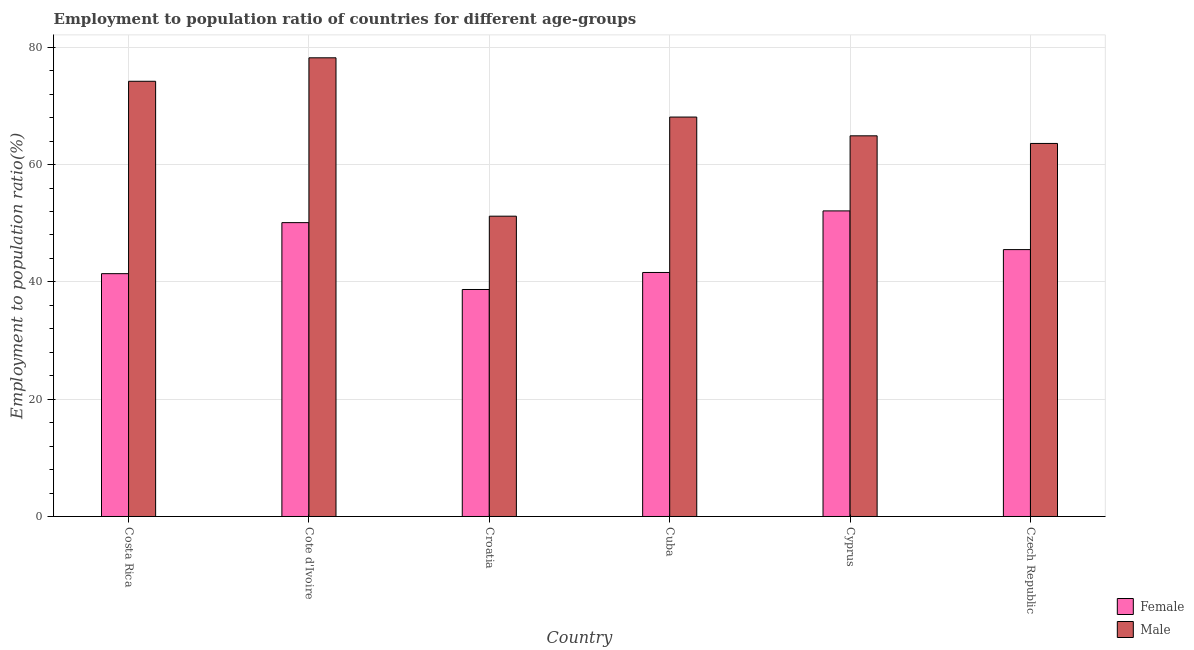How many different coloured bars are there?
Provide a short and direct response. 2. How many groups of bars are there?
Offer a very short reply. 6. Are the number of bars per tick equal to the number of legend labels?
Ensure brevity in your answer.  Yes. Are the number of bars on each tick of the X-axis equal?
Offer a very short reply. Yes. What is the label of the 6th group of bars from the left?
Ensure brevity in your answer.  Czech Republic. In how many cases, is the number of bars for a given country not equal to the number of legend labels?
Provide a succinct answer. 0. What is the employment to population ratio(female) in Cyprus?
Your response must be concise. 52.1. Across all countries, what is the maximum employment to population ratio(male)?
Keep it short and to the point. 78.2. Across all countries, what is the minimum employment to population ratio(male)?
Your answer should be compact. 51.2. In which country was the employment to population ratio(female) maximum?
Your answer should be compact. Cyprus. In which country was the employment to population ratio(female) minimum?
Provide a succinct answer. Croatia. What is the total employment to population ratio(female) in the graph?
Your response must be concise. 269.4. What is the difference between the employment to population ratio(male) in Cote d'Ivoire and that in Croatia?
Make the answer very short. 27. What is the difference between the employment to population ratio(male) in Cuba and the employment to population ratio(female) in Cote d'Ivoire?
Your answer should be very brief. 18. What is the average employment to population ratio(male) per country?
Keep it short and to the point. 66.7. What is the difference between the employment to population ratio(male) and employment to population ratio(female) in Cyprus?
Keep it short and to the point. 12.8. What is the ratio of the employment to population ratio(male) in Cote d'Ivoire to that in Cuba?
Your response must be concise. 1.15. Is the employment to population ratio(female) in Costa Rica less than that in Cyprus?
Keep it short and to the point. Yes. Is the difference between the employment to population ratio(female) in Croatia and Cuba greater than the difference between the employment to population ratio(male) in Croatia and Cuba?
Provide a succinct answer. Yes. What is the difference between the highest and the lowest employment to population ratio(female)?
Give a very brief answer. 13.4. In how many countries, is the employment to population ratio(male) greater than the average employment to population ratio(male) taken over all countries?
Ensure brevity in your answer.  3. What does the 1st bar from the left in Costa Rica represents?
Give a very brief answer. Female. What does the 2nd bar from the right in Cote d'Ivoire represents?
Provide a succinct answer. Female. What is the difference between two consecutive major ticks on the Y-axis?
Give a very brief answer. 20. Where does the legend appear in the graph?
Offer a very short reply. Bottom right. How many legend labels are there?
Ensure brevity in your answer.  2. What is the title of the graph?
Make the answer very short. Employment to population ratio of countries for different age-groups. Does "From World Bank" appear as one of the legend labels in the graph?
Make the answer very short. No. What is the label or title of the X-axis?
Offer a very short reply. Country. What is the label or title of the Y-axis?
Your answer should be very brief. Employment to population ratio(%). What is the Employment to population ratio(%) of Female in Costa Rica?
Your answer should be very brief. 41.4. What is the Employment to population ratio(%) of Male in Costa Rica?
Your answer should be very brief. 74.2. What is the Employment to population ratio(%) of Female in Cote d'Ivoire?
Provide a succinct answer. 50.1. What is the Employment to population ratio(%) of Male in Cote d'Ivoire?
Ensure brevity in your answer.  78.2. What is the Employment to population ratio(%) of Female in Croatia?
Keep it short and to the point. 38.7. What is the Employment to population ratio(%) in Male in Croatia?
Keep it short and to the point. 51.2. What is the Employment to population ratio(%) of Female in Cuba?
Ensure brevity in your answer.  41.6. What is the Employment to population ratio(%) in Male in Cuba?
Offer a terse response. 68.1. What is the Employment to population ratio(%) of Female in Cyprus?
Your answer should be very brief. 52.1. What is the Employment to population ratio(%) in Male in Cyprus?
Offer a very short reply. 64.9. What is the Employment to population ratio(%) of Female in Czech Republic?
Give a very brief answer. 45.5. What is the Employment to population ratio(%) of Male in Czech Republic?
Offer a terse response. 63.6. Across all countries, what is the maximum Employment to population ratio(%) of Female?
Your answer should be very brief. 52.1. Across all countries, what is the maximum Employment to population ratio(%) in Male?
Provide a succinct answer. 78.2. Across all countries, what is the minimum Employment to population ratio(%) in Female?
Offer a very short reply. 38.7. Across all countries, what is the minimum Employment to population ratio(%) in Male?
Your answer should be compact. 51.2. What is the total Employment to population ratio(%) in Female in the graph?
Your response must be concise. 269.4. What is the total Employment to population ratio(%) in Male in the graph?
Provide a short and direct response. 400.2. What is the difference between the Employment to population ratio(%) of Male in Costa Rica and that in Cote d'Ivoire?
Ensure brevity in your answer.  -4. What is the difference between the Employment to population ratio(%) of Male in Costa Rica and that in Croatia?
Provide a short and direct response. 23. What is the difference between the Employment to population ratio(%) of Female in Costa Rica and that in Cyprus?
Offer a very short reply. -10.7. What is the difference between the Employment to population ratio(%) of Male in Costa Rica and that in Czech Republic?
Offer a very short reply. 10.6. What is the difference between the Employment to population ratio(%) in Male in Cote d'Ivoire and that in Croatia?
Provide a succinct answer. 27. What is the difference between the Employment to population ratio(%) in Female in Cote d'Ivoire and that in Cyprus?
Make the answer very short. -2. What is the difference between the Employment to population ratio(%) in Male in Cote d'Ivoire and that in Czech Republic?
Ensure brevity in your answer.  14.6. What is the difference between the Employment to population ratio(%) of Male in Croatia and that in Cuba?
Keep it short and to the point. -16.9. What is the difference between the Employment to population ratio(%) in Female in Croatia and that in Cyprus?
Give a very brief answer. -13.4. What is the difference between the Employment to population ratio(%) of Male in Croatia and that in Cyprus?
Your answer should be compact. -13.7. What is the difference between the Employment to population ratio(%) of Male in Croatia and that in Czech Republic?
Offer a terse response. -12.4. What is the difference between the Employment to population ratio(%) of Male in Cuba and that in Cyprus?
Ensure brevity in your answer.  3.2. What is the difference between the Employment to population ratio(%) in Male in Cuba and that in Czech Republic?
Your answer should be very brief. 4.5. What is the difference between the Employment to population ratio(%) of Female in Cyprus and that in Czech Republic?
Provide a succinct answer. 6.6. What is the difference between the Employment to population ratio(%) of Male in Cyprus and that in Czech Republic?
Your answer should be compact. 1.3. What is the difference between the Employment to population ratio(%) of Female in Costa Rica and the Employment to population ratio(%) of Male in Cote d'Ivoire?
Your response must be concise. -36.8. What is the difference between the Employment to population ratio(%) in Female in Costa Rica and the Employment to population ratio(%) in Male in Croatia?
Offer a terse response. -9.8. What is the difference between the Employment to population ratio(%) of Female in Costa Rica and the Employment to population ratio(%) of Male in Cuba?
Ensure brevity in your answer.  -26.7. What is the difference between the Employment to population ratio(%) of Female in Costa Rica and the Employment to population ratio(%) of Male in Cyprus?
Keep it short and to the point. -23.5. What is the difference between the Employment to population ratio(%) in Female in Costa Rica and the Employment to population ratio(%) in Male in Czech Republic?
Offer a terse response. -22.2. What is the difference between the Employment to population ratio(%) of Female in Cote d'Ivoire and the Employment to population ratio(%) of Male in Cyprus?
Give a very brief answer. -14.8. What is the difference between the Employment to population ratio(%) of Female in Croatia and the Employment to population ratio(%) of Male in Cuba?
Offer a very short reply. -29.4. What is the difference between the Employment to population ratio(%) in Female in Croatia and the Employment to population ratio(%) in Male in Cyprus?
Your response must be concise. -26.2. What is the difference between the Employment to population ratio(%) of Female in Croatia and the Employment to population ratio(%) of Male in Czech Republic?
Your answer should be very brief. -24.9. What is the difference between the Employment to population ratio(%) in Female in Cuba and the Employment to population ratio(%) in Male in Cyprus?
Provide a short and direct response. -23.3. What is the average Employment to population ratio(%) in Female per country?
Provide a short and direct response. 44.9. What is the average Employment to population ratio(%) of Male per country?
Provide a short and direct response. 66.7. What is the difference between the Employment to population ratio(%) in Female and Employment to population ratio(%) in Male in Costa Rica?
Your answer should be very brief. -32.8. What is the difference between the Employment to population ratio(%) of Female and Employment to population ratio(%) of Male in Cote d'Ivoire?
Give a very brief answer. -28.1. What is the difference between the Employment to population ratio(%) of Female and Employment to population ratio(%) of Male in Croatia?
Keep it short and to the point. -12.5. What is the difference between the Employment to population ratio(%) in Female and Employment to population ratio(%) in Male in Cuba?
Ensure brevity in your answer.  -26.5. What is the difference between the Employment to population ratio(%) in Female and Employment to population ratio(%) in Male in Cyprus?
Your answer should be compact. -12.8. What is the difference between the Employment to population ratio(%) of Female and Employment to population ratio(%) of Male in Czech Republic?
Your answer should be very brief. -18.1. What is the ratio of the Employment to population ratio(%) in Female in Costa Rica to that in Cote d'Ivoire?
Your response must be concise. 0.83. What is the ratio of the Employment to population ratio(%) of Male in Costa Rica to that in Cote d'Ivoire?
Make the answer very short. 0.95. What is the ratio of the Employment to population ratio(%) in Female in Costa Rica to that in Croatia?
Keep it short and to the point. 1.07. What is the ratio of the Employment to population ratio(%) of Male in Costa Rica to that in Croatia?
Provide a succinct answer. 1.45. What is the ratio of the Employment to population ratio(%) of Female in Costa Rica to that in Cuba?
Your response must be concise. 1. What is the ratio of the Employment to population ratio(%) of Male in Costa Rica to that in Cuba?
Your answer should be compact. 1.09. What is the ratio of the Employment to population ratio(%) in Female in Costa Rica to that in Cyprus?
Make the answer very short. 0.79. What is the ratio of the Employment to population ratio(%) in Male in Costa Rica to that in Cyprus?
Give a very brief answer. 1.14. What is the ratio of the Employment to population ratio(%) of Female in Costa Rica to that in Czech Republic?
Offer a very short reply. 0.91. What is the ratio of the Employment to population ratio(%) in Male in Costa Rica to that in Czech Republic?
Give a very brief answer. 1.17. What is the ratio of the Employment to population ratio(%) of Female in Cote d'Ivoire to that in Croatia?
Offer a very short reply. 1.29. What is the ratio of the Employment to population ratio(%) in Male in Cote d'Ivoire to that in Croatia?
Make the answer very short. 1.53. What is the ratio of the Employment to population ratio(%) in Female in Cote d'Ivoire to that in Cuba?
Your response must be concise. 1.2. What is the ratio of the Employment to population ratio(%) in Male in Cote d'Ivoire to that in Cuba?
Give a very brief answer. 1.15. What is the ratio of the Employment to population ratio(%) in Female in Cote d'Ivoire to that in Cyprus?
Give a very brief answer. 0.96. What is the ratio of the Employment to population ratio(%) of Male in Cote d'Ivoire to that in Cyprus?
Ensure brevity in your answer.  1.2. What is the ratio of the Employment to population ratio(%) of Female in Cote d'Ivoire to that in Czech Republic?
Provide a succinct answer. 1.1. What is the ratio of the Employment to population ratio(%) of Male in Cote d'Ivoire to that in Czech Republic?
Your answer should be compact. 1.23. What is the ratio of the Employment to population ratio(%) in Female in Croatia to that in Cuba?
Your response must be concise. 0.93. What is the ratio of the Employment to population ratio(%) of Male in Croatia to that in Cuba?
Offer a very short reply. 0.75. What is the ratio of the Employment to population ratio(%) in Female in Croatia to that in Cyprus?
Keep it short and to the point. 0.74. What is the ratio of the Employment to population ratio(%) of Male in Croatia to that in Cyprus?
Offer a very short reply. 0.79. What is the ratio of the Employment to population ratio(%) in Female in Croatia to that in Czech Republic?
Ensure brevity in your answer.  0.85. What is the ratio of the Employment to population ratio(%) in Male in Croatia to that in Czech Republic?
Provide a succinct answer. 0.81. What is the ratio of the Employment to population ratio(%) in Female in Cuba to that in Cyprus?
Your answer should be compact. 0.8. What is the ratio of the Employment to population ratio(%) of Male in Cuba to that in Cyprus?
Offer a very short reply. 1.05. What is the ratio of the Employment to population ratio(%) of Female in Cuba to that in Czech Republic?
Give a very brief answer. 0.91. What is the ratio of the Employment to population ratio(%) in Male in Cuba to that in Czech Republic?
Make the answer very short. 1.07. What is the ratio of the Employment to population ratio(%) in Female in Cyprus to that in Czech Republic?
Offer a very short reply. 1.15. What is the ratio of the Employment to population ratio(%) of Male in Cyprus to that in Czech Republic?
Your answer should be very brief. 1.02. What is the difference between the highest and the second highest Employment to population ratio(%) of Female?
Give a very brief answer. 2. What is the difference between the highest and the second highest Employment to population ratio(%) in Male?
Keep it short and to the point. 4. 